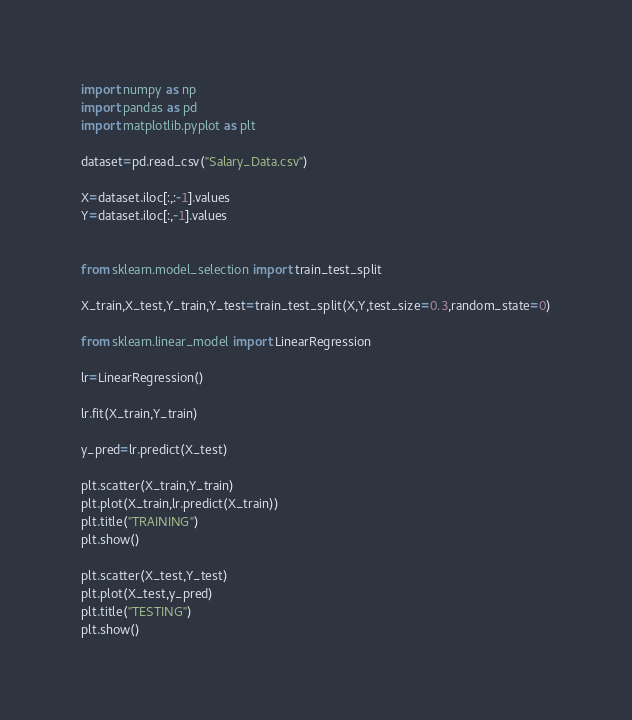<code> <loc_0><loc_0><loc_500><loc_500><_Python_>import numpy as np 
import pandas as pd
import matplotlib.pyplot as plt

dataset=pd.read_csv("Salary_Data.csv")

X=dataset.iloc[:,:-1].values
Y=dataset.iloc[:,-1].values


from sklearn.model_selection import train_test_split

X_train,X_test,Y_train,Y_test=train_test_split(X,Y,test_size=0.3,random_state=0)

from sklearn.linear_model import LinearRegression

lr=LinearRegression()

lr.fit(X_train,Y_train)

y_pred=lr.predict(X_test)

plt.scatter(X_train,Y_train)
plt.plot(X_train,lr.predict(X_train))
plt.title("TRAINING")
plt.show()

plt.scatter(X_test,Y_test)
plt.plot(X_test,y_pred)
plt.title("TESTING")
plt.show()</code> 